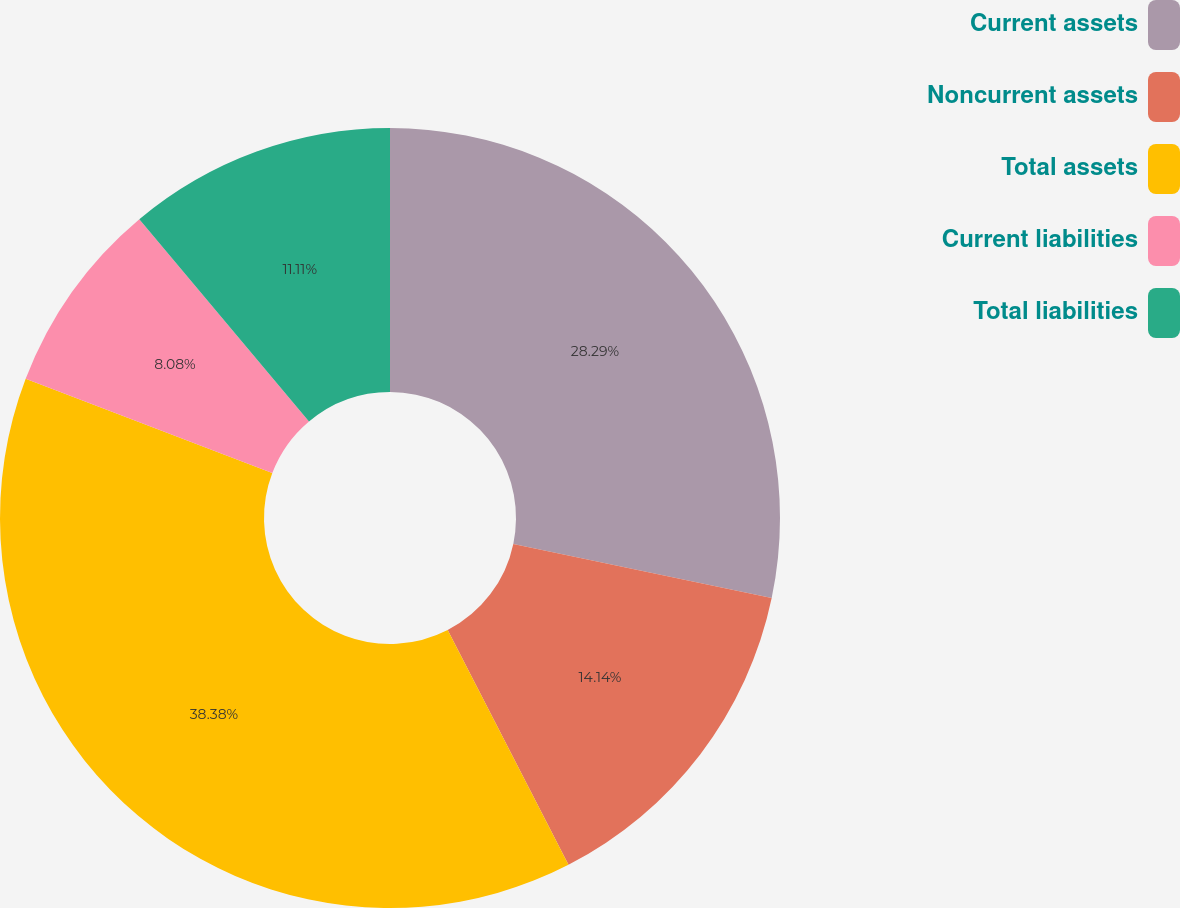<chart> <loc_0><loc_0><loc_500><loc_500><pie_chart><fcel>Current assets<fcel>Noncurrent assets<fcel>Total assets<fcel>Current liabilities<fcel>Total liabilities<nl><fcel>28.29%<fcel>14.14%<fcel>38.37%<fcel>8.08%<fcel>11.11%<nl></chart> 